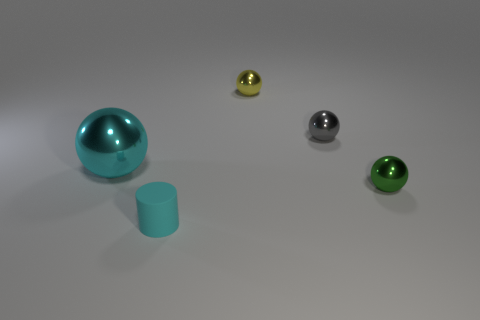There is a matte thing that is the same color as the big metal sphere; what is its shape?
Provide a short and direct response. Cylinder. How many other things are there of the same color as the small rubber cylinder?
Your response must be concise. 1. There is a small metal thing in front of the cyan metallic ball; does it have the same color as the large shiny thing?
Ensure brevity in your answer.  No. What size is the gray thing that is the same shape as the tiny yellow object?
Make the answer very short. Small. What number of things are the same material as the big sphere?
Your response must be concise. 3. Is there a tiny object that is on the left side of the small metallic object that is in front of the cyan thing on the left side of the cyan matte thing?
Provide a succinct answer. Yes. What is the shape of the small cyan rubber thing?
Give a very brief answer. Cylinder. Are the tiny sphere behind the tiny gray ball and the cyan object that is in front of the green metallic object made of the same material?
Your answer should be very brief. No. How many big shiny things are the same color as the matte thing?
Ensure brevity in your answer.  1. There is a small thing that is left of the tiny green shiny thing and in front of the tiny gray thing; what is its shape?
Your response must be concise. Cylinder. 